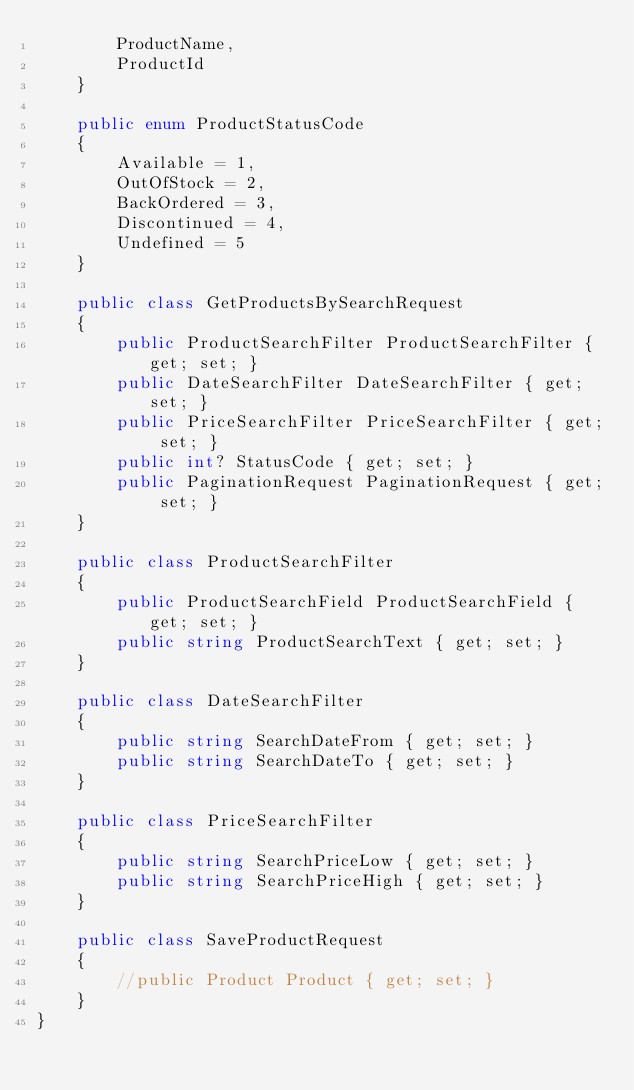<code> <loc_0><loc_0><loc_500><loc_500><_C#_>        ProductName,
        ProductId
    }

    public enum ProductStatusCode
    {
        Available = 1,
        OutOfStock = 2,
        BackOrdered = 3,
        Discontinued = 4,
        Undefined = 5
    }

    public class GetProductsBySearchRequest
    {
        public ProductSearchFilter ProductSearchFilter { get; set; }
        public DateSearchFilter DateSearchFilter { get; set; }
        public PriceSearchFilter PriceSearchFilter { get; set; }
        public int? StatusCode { get; set; }
        public PaginationRequest PaginationRequest { get; set; }
    }

    public class ProductSearchFilter
    {
        public ProductSearchField ProductSearchField { get; set; }
        public string ProductSearchText { get; set; }
    }

    public class DateSearchFilter
    {
        public string SearchDateFrom { get; set; }
        public string SearchDateTo { get; set; }
    }

    public class PriceSearchFilter
    {
        public string SearchPriceLow { get; set; }
        public string SearchPriceHigh { get; set; }
    }

    public class SaveProductRequest
    {
        //public Product Product { get; set; }
    }
}</code> 